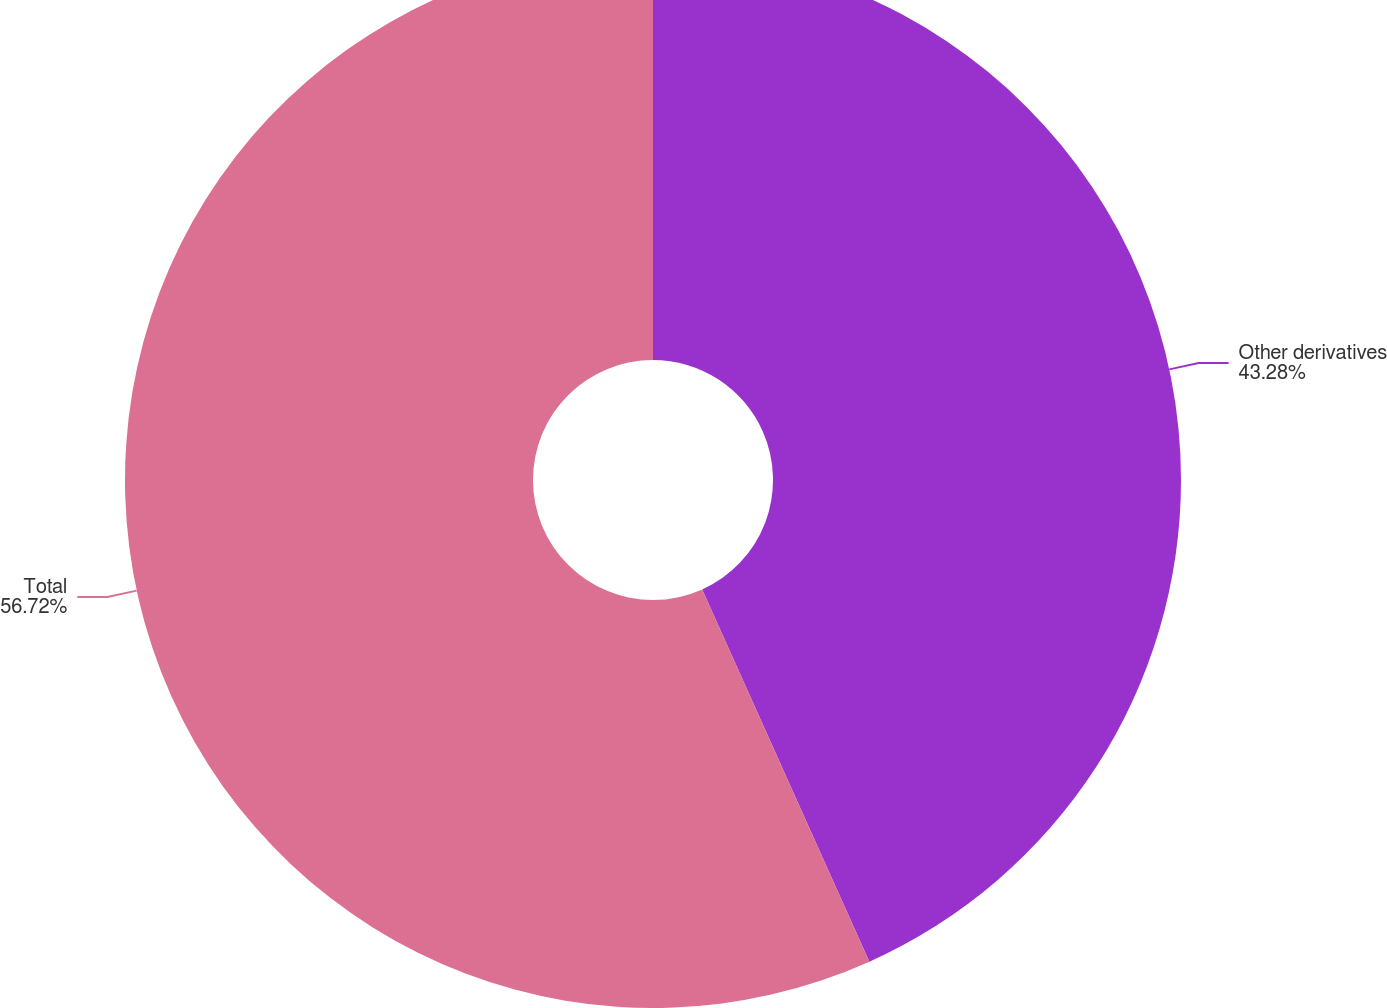Convert chart to OTSL. <chart><loc_0><loc_0><loc_500><loc_500><pie_chart><fcel>Other derivatives<fcel>Total<nl><fcel>43.28%<fcel>56.72%<nl></chart> 